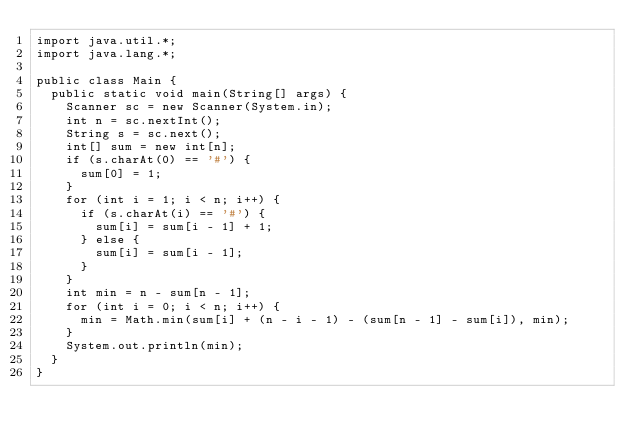Convert code to text. <code><loc_0><loc_0><loc_500><loc_500><_Java_>import java.util.*;
import java.lang.*;

public class Main {
	public static void main(String[] args) {
		Scanner sc = new Scanner(System.in);
		int n = sc.nextInt();
		String s = sc.next();
		int[] sum = new int[n];
		if (s.charAt(0) == '#') {
			sum[0] = 1;
		}
		for (int i = 1; i < n; i++) {
			if (s.charAt(i) == '#') {
				sum[i] = sum[i - 1] + 1;
			} else {
				sum[i] = sum[i - 1];
			}
		}
		int min = n - sum[n - 1];
		for (int i = 0; i < n; i++) {
			min = Math.min(sum[i] + (n - i - 1) - (sum[n - 1] - sum[i]), min);
		}
		System.out.println(min);
	}
}</code> 